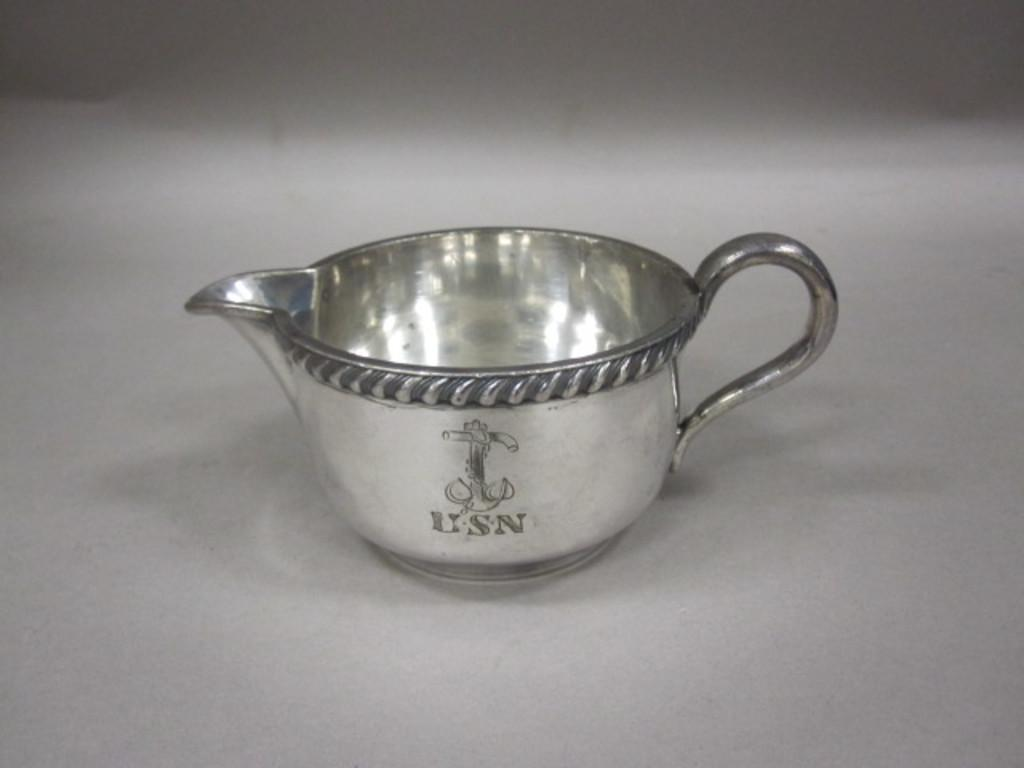<image>
Present a compact description of the photo's key features. A silver tea cup of the USN sits on a surface. 